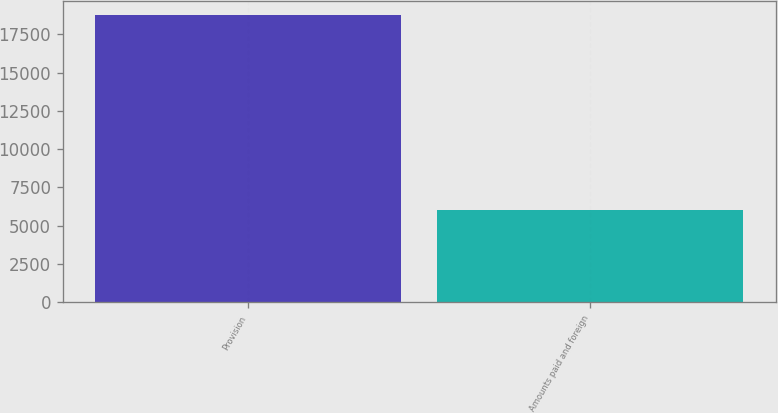<chart> <loc_0><loc_0><loc_500><loc_500><bar_chart><fcel>Provision<fcel>Amounts paid and foreign<nl><fcel>18746<fcel>5996<nl></chart> 